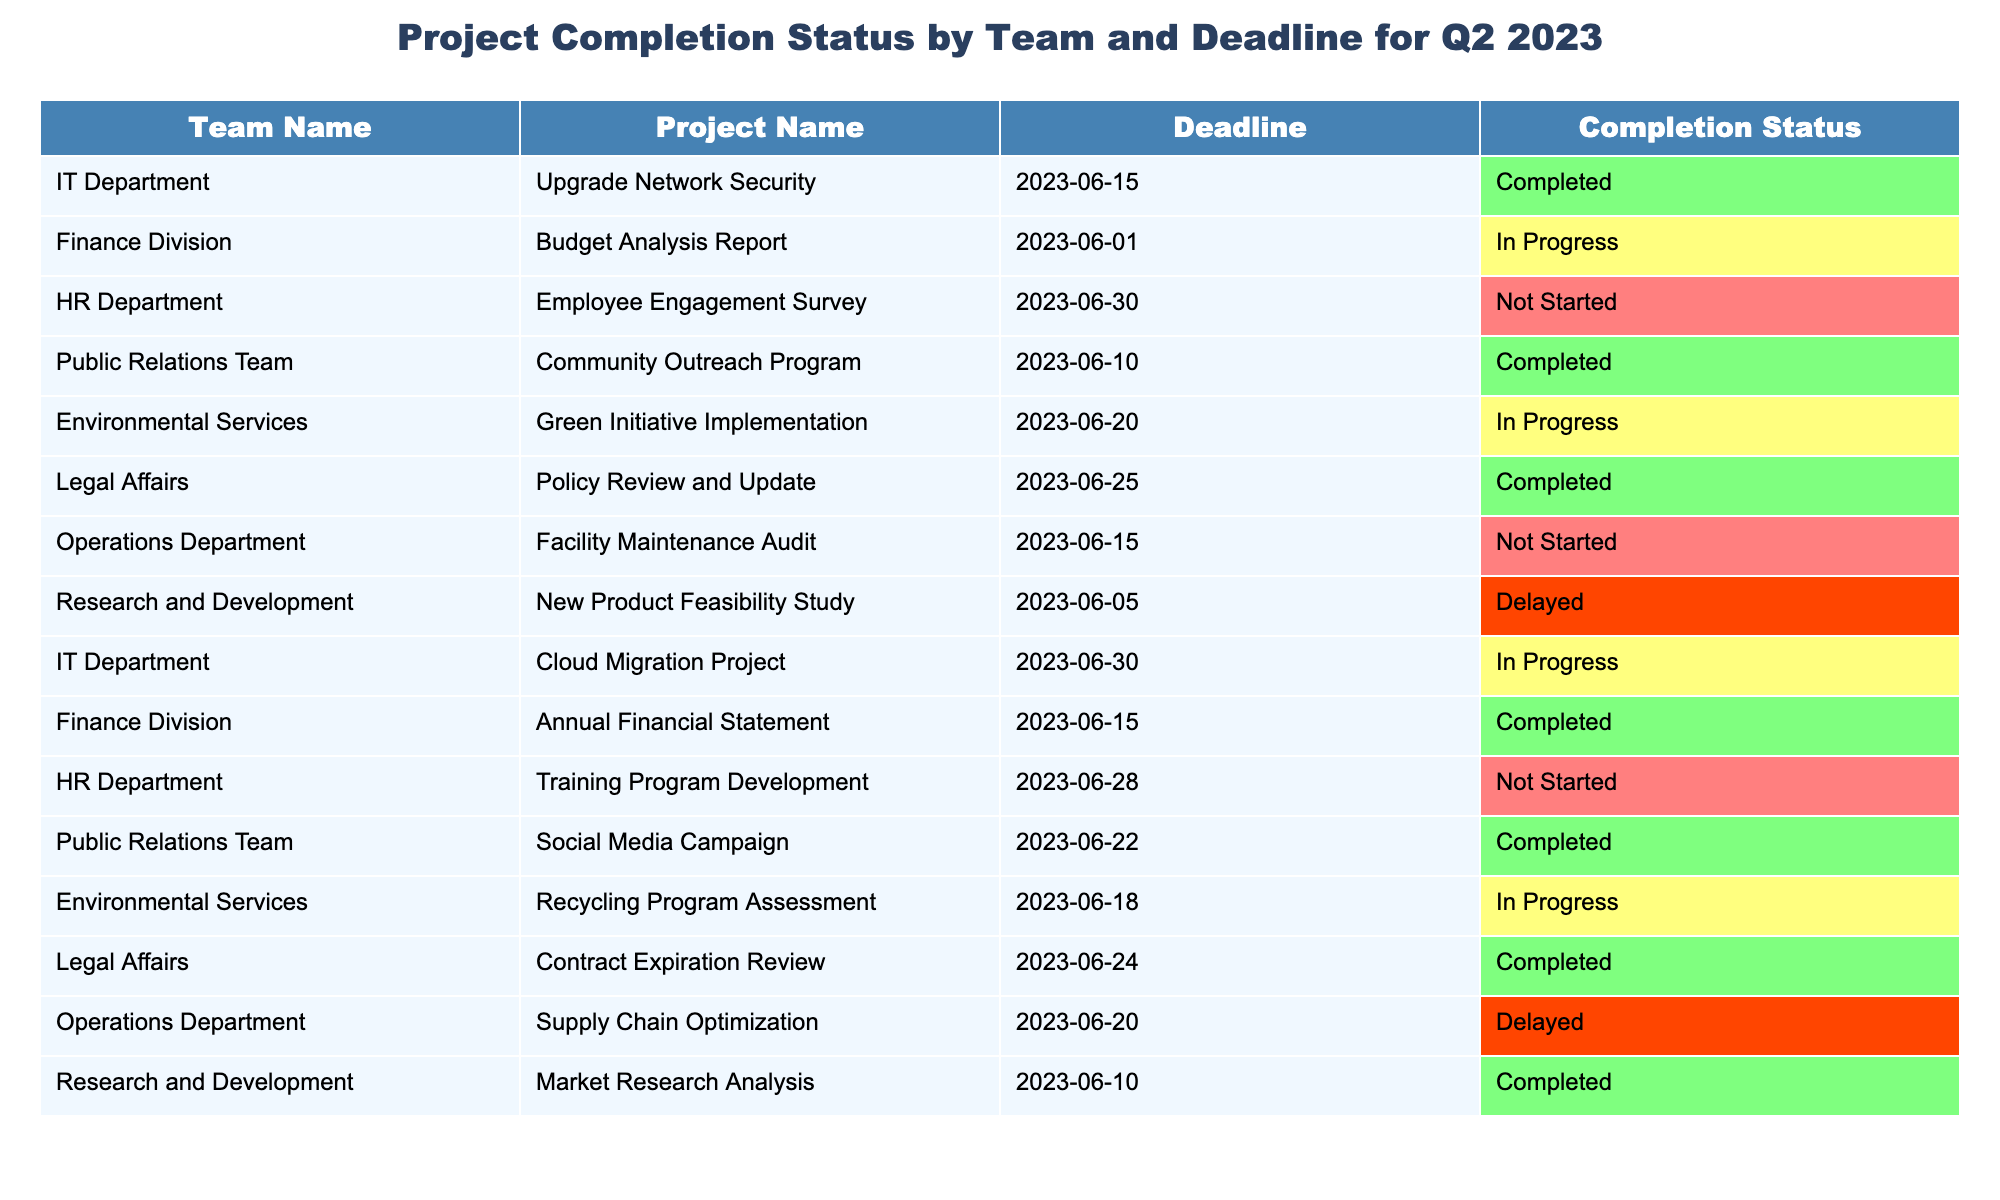What is the completion status of the 'Employee Engagement Survey' project? The 'Employee Engagement Survey' project is listed under the HR Department and its completion status indicates "Not Started".
Answer: Not Started How many projects have been marked as 'Completed'? By counting the number of projects with the status 'Completed', we find there are 5 such projects.
Answer: 5 Which team has the project with the earliest deadline? The project with the earliest deadline is 'Budget Analysis Report' from the Finance Division, due on 2023-06-01.
Answer: Finance Division Is there any project with a status of 'Delayed'? Yes, there are two projects marked as 'Delayed': 'New Product Feasibility Study' and 'Supply Chain Optimization'.
Answer: Yes What is the completion rate for the projects in the IT Department? The IT Department has 2 projects: one 'Completed' and one 'In Progress', making the completion rate 1 out of 2 or 50%.
Answer: 50% Which project from the Public Relations Team has not been completed? The 'Social Media Campaign' from the Public Relations Team has been completed, while the 'Community Outreach Program' has also been completed. Thus, all projects are completed.
Answer: All completed Which department has the most projects listed in the table? By counting the projects listed for each department, the IT Department, Finance Division, and Public Relations Team each have 2 projects, which is the highest.
Answer: IT Department, Finance Division, Public Relations Team How many projects are marked as 'In Progress'? There are 3 projects currently marked as 'In Progress': 'Budget Analysis Report', 'Cloud Migration Project', and 'Recycling Program Assessment'.
Answer: 3 What is the deadline for the 'Green Initiative Implementation' project? The deadline for the 'Green Initiative Implementation' project is listed as 2023-06-20.
Answer: 2023-06-20 Among the projects from the Finance Division, which one has been completed? The 'Annual Financial Statement' project has been completed while the 'Budget Analysis Report' is still in progress.
Answer: Annual Financial Statement If we total the number of 'Not Started' projects, how many are there? There are 3 projects that have not been started: 'Employee Engagement Survey', 'Facility Maintenance Audit', and 'Training Program Development'.
Answer: 3 